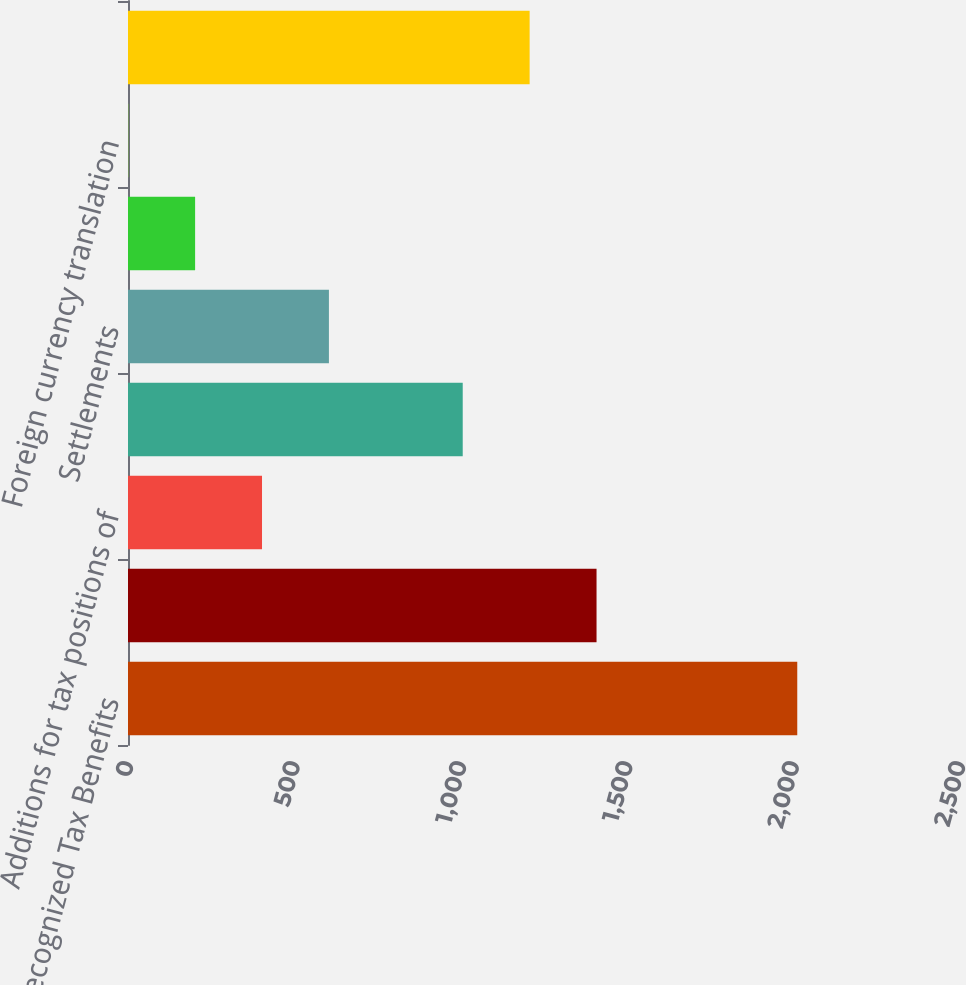<chart> <loc_0><loc_0><loc_500><loc_500><bar_chart><fcel>Unrecognized Tax Benefits<fcel>Balance at beginning of year<fcel>Additions for tax positions of<fcel>Reductions for tax positions<fcel>Settlements<fcel>Statute of limitations<fcel>Foreign currency translation<fcel>Balance at End of Year<nl><fcel>2011<fcel>1407.88<fcel>402.68<fcel>1005.8<fcel>603.72<fcel>201.64<fcel>0.6<fcel>1206.84<nl></chart> 